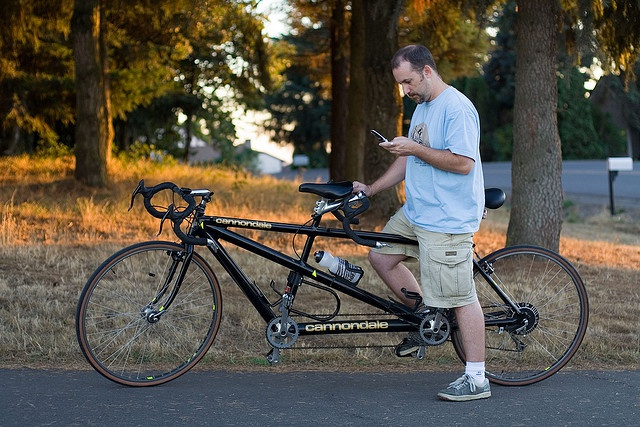Describe the objects in this image and their specific colors. I can see bicycle in black, gray, and darkgray tones, people in black, darkgray, lightblue, and gray tones, bottle in black, darkgray, and gray tones, and cell phone in black, gray, lavender, and darkgray tones in this image. 